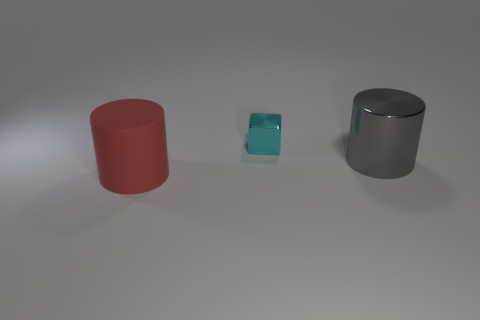There is a shiny thing that is left of the big gray metal cylinder on the right side of the cyan shiny object; how big is it?
Provide a succinct answer. Small. Is there a tiny cyan cube made of the same material as the red cylinder?
Provide a short and direct response. No. There is a gray thing that is behind the cylinder that is to the left of the cylinder that is behind the rubber cylinder; what shape is it?
Give a very brief answer. Cylinder. Is there anything else that has the same size as the cyan metal cube?
Your answer should be compact. No. There is a large gray cylinder; are there any red objects on the right side of it?
Make the answer very short. No. What number of tiny yellow matte things are the same shape as the big gray thing?
Your answer should be compact. 0. There is a cylinder that is right of the big red thing that is in front of the metal object on the left side of the large metallic object; what color is it?
Give a very brief answer. Gray. Does the large thing left of the gray metallic cylinder have the same material as the big thing behind the large red matte thing?
Keep it short and to the point. No. How many things are big objects that are to the right of the cube or big blue objects?
Make the answer very short. 1. How many objects are either matte objects or small shiny blocks behind the big gray cylinder?
Offer a terse response. 2. 